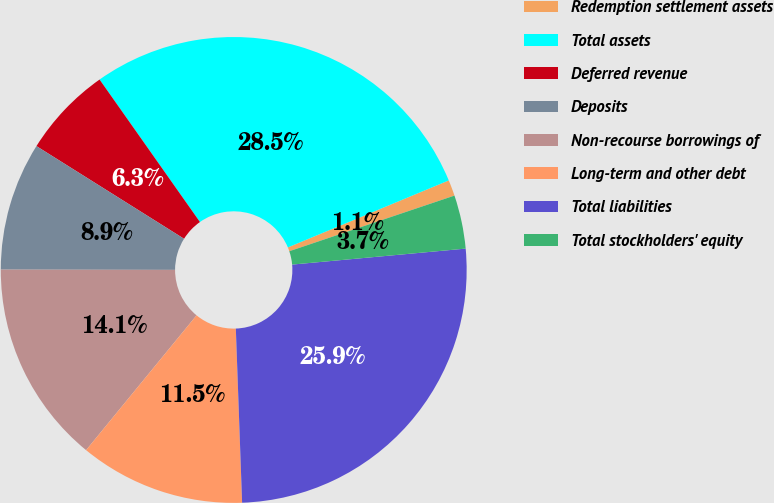Convert chart. <chart><loc_0><loc_0><loc_500><loc_500><pie_chart><fcel>Redemption settlement assets<fcel>Total assets<fcel>Deferred revenue<fcel>Deposits<fcel>Non-recourse borrowings of<fcel>Long-term and other debt<fcel>Total liabilities<fcel>Total stockholders' equity<nl><fcel>1.11%<fcel>28.49%<fcel>6.31%<fcel>8.9%<fcel>14.1%<fcel>11.5%<fcel>25.89%<fcel>3.71%<nl></chart> 